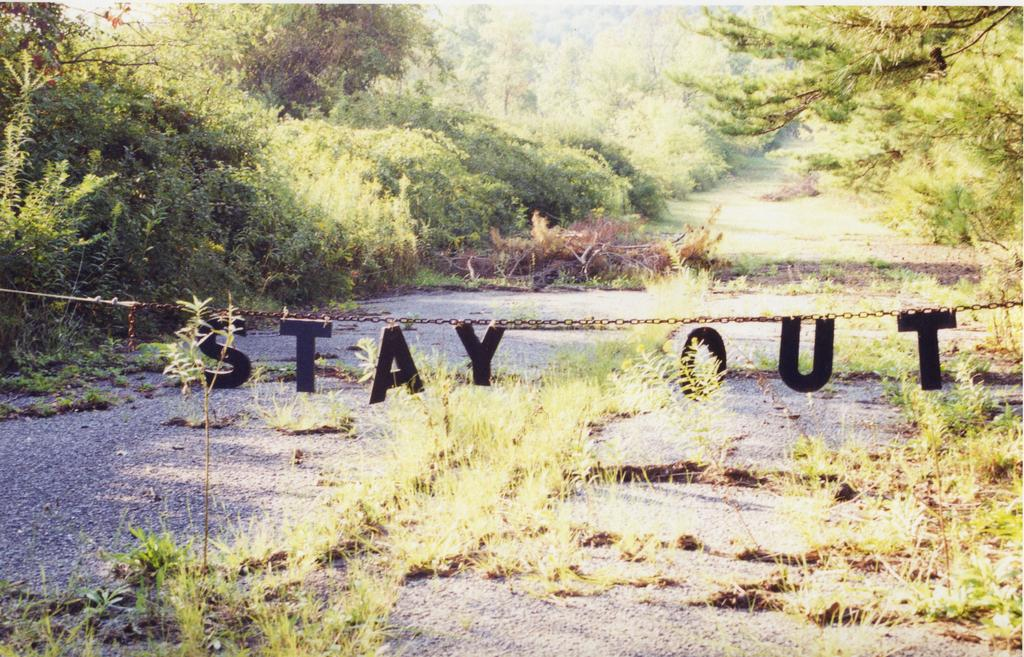What type of terrain is visible at the bottom of the image? There is grass and mud at the bottom of the image. What can be seen on the left side of the image? There are trees on the left side of the image. What is present on the right side of the image? There are trees on the right side of the image as well. What is written or depicted in the middle of the image? There is a text in the middle of the image. What color is the nail painted in the image? There is no nail present in the image. Can you see any stars in the image? There are no stars visible in the image. 